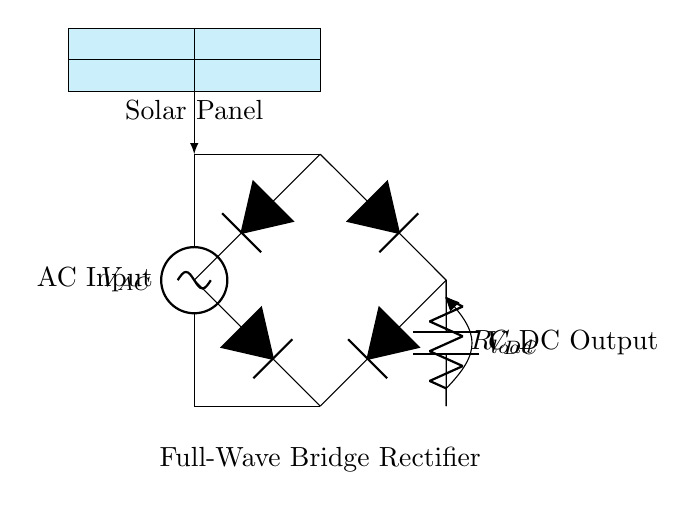What is the type of rectifier shown in the diagram? The diagram shows a full-wave bridge rectifier as indicated by the arrangement of four diodes. This configuration allows both halves of the AC waveform to be used to produce a positive DC output.
Answer: full-wave bridge rectifier How many diodes are used in the rectifier? There are four diodes depicted in the bridge rectifier configuration. Each diode conducts during different half cycles of the AC input to ensure that the output is always positive.
Answer: four What is the function of the load resistor in the circuit? The load resistor is connected in the output path to limit the current flowing through the circuit and to provide a load for the output voltage. It is essential for utilizing the power converted from AC to DC.
Answer: limit current What voltage type is provided by the solar panel? The solar panel provides alternating current as indicated by the AC label at the input, which is then rectified by the bridge rectifier.
Answer: alternating current What component smooths the output voltage? The smoothing capacitor (labelled as C) is used to reduce voltage fluctuations in the DC output, by charging during high voltage and discharging when the voltage drops, thus providing a more stable DC supply.
Answer: smoothing capacitor In what configuration are the diodes arranged in this rectifier? The diodes are arranged in a bridge configuration, allowing both halves of the AC input to be converted into DC. This arrangement ensures that no matter the polarity of the input voltage, the output will always be positive.
Answer: bridge configuration What is the voltage output type at the output of the circuit? The output of the circuit is direct current, as the rectifier converts the alternating current input from the solar panel into a usable form of power for electrical devices.
Answer: direct current 